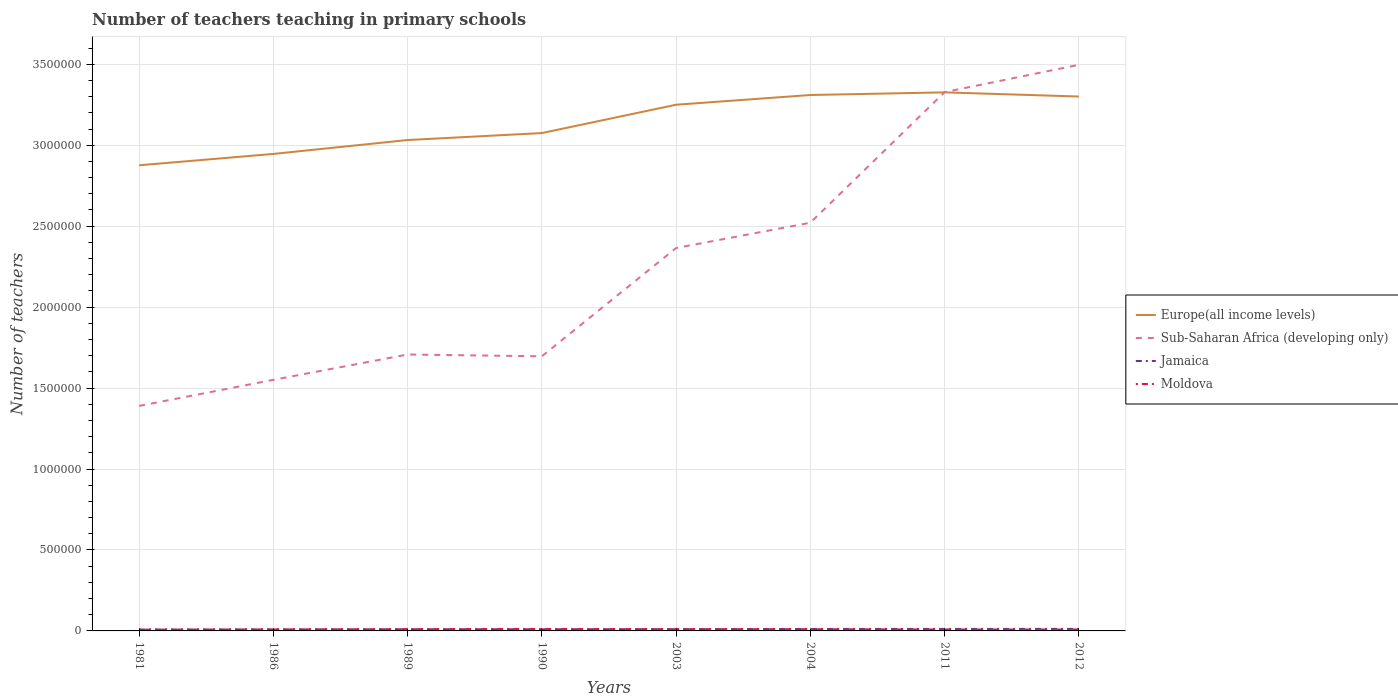How many different coloured lines are there?
Your response must be concise. 4. Does the line corresponding to Jamaica intersect with the line corresponding to Sub-Saharan Africa (developing only)?
Provide a short and direct response. No. Is the number of lines equal to the number of legend labels?
Provide a short and direct response. Yes. Across all years, what is the maximum number of teachers teaching in primary schools in Jamaica?
Provide a succinct answer. 8676. What is the total number of teachers teaching in primary schools in Moldova in the graph?
Offer a terse response. -4067. What is the difference between the highest and the second highest number of teachers teaching in primary schools in Moldova?
Provide a short and direct response. 4067. Is the number of teachers teaching in primary schools in Europe(all income levels) strictly greater than the number of teachers teaching in primary schools in Jamaica over the years?
Your response must be concise. No. How many years are there in the graph?
Make the answer very short. 8. Does the graph contain any zero values?
Your answer should be compact. No. Does the graph contain grids?
Keep it short and to the point. Yes. How many legend labels are there?
Your answer should be compact. 4. How are the legend labels stacked?
Your response must be concise. Vertical. What is the title of the graph?
Your answer should be very brief. Number of teachers teaching in primary schools. Does "Congo (Democratic)" appear as one of the legend labels in the graph?
Provide a short and direct response. No. What is the label or title of the X-axis?
Your response must be concise. Years. What is the label or title of the Y-axis?
Offer a very short reply. Number of teachers. What is the Number of teachers of Europe(all income levels) in 1981?
Keep it short and to the point. 2.88e+06. What is the Number of teachers of Sub-Saharan Africa (developing only) in 1981?
Your answer should be very brief. 1.39e+06. What is the Number of teachers of Jamaica in 1981?
Keep it short and to the point. 8676. What is the Number of teachers of Moldova in 1981?
Make the answer very short. 8003. What is the Number of teachers of Europe(all income levels) in 1986?
Your answer should be compact. 2.95e+06. What is the Number of teachers of Sub-Saharan Africa (developing only) in 1986?
Offer a very short reply. 1.55e+06. What is the Number of teachers in Jamaica in 1986?
Provide a succinct answer. 9648. What is the Number of teachers in Moldova in 1986?
Ensure brevity in your answer.  9500. What is the Number of teachers of Europe(all income levels) in 1989?
Provide a short and direct response. 3.03e+06. What is the Number of teachers in Sub-Saharan Africa (developing only) in 1989?
Give a very brief answer. 1.71e+06. What is the Number of teachers in Jamaica in 1989?
Provide a succinct answer. 1.03e+04. What is the Number of teachers of Moldova in 1989?
Your response must be concise. 1.11e+04. What is the Number of teachers in Europe(all income levels) in 1990?
Your response must be concise. 3.07e+06. What is the Number of teachers in Sub-Saharan Africa (developing only) in 1990?
Give a very brief answer. 1.70e+06. What is the Number of teachers in Jamaica in 1990?
Provide a succinct answer. 1.01e+04. What is the Number of teachers of Moldova in 1990?
Make the answer very short. 1.21e+04. What is the Number of teachers of Europe(all income levels) in 2003?
Your answer should be compact. 3.25e+06. What is the Number of teachers in Sub-Saharan Africa (developing only) in 2003?
Offer a terse response. 2.37e+06. What is the Number of teachers in Jamaica in 2003?
Offer a terse response. 1.10e+04. What is the Number of teachers in Moldova in 2003?
Keep it short and to the point. 1.11e+04. What is the Number of teachers in Europe(all income levels) in 2004?
Offer a very short reply. 3.31e+06. What is the Number of teachers in Sub-Saharan Africa (developing only) in 2004?
Your response must be concise. 2.52e+06. What is the Number of teachers of Jamaica in 2004?
Ensure brevity in your answer.  1.20e+04. What is the Number of teachers in Moldova in 2004?
Provide a succinct answer. 1.05e+04. What is the Number of teachers of Europe(all income levels) in 2011?
Provide a short and direct response. 3.33e+06. What is the Number of teachers in Sub-Saharan Africa (developing only) in 2011?
Offer a very short reply. 3.33e+06. What is the Number of teachers in Jamaica in 2011?
Your answer should be very brief. 1.24e+04. What is the Number of teachers of Moldova in 2011?
Ensure brevity in your answer.  9037. What is the Number of teachers of Europe(all income levels) in 2012?
Offer a very short reply. 3.30e+06. What is the Number of teachers in Sub-Saharan Africa (developing only) in 2012?
Provide a succinct answer. 3.50e+06. What is the Number of teachers of Jamaica in 2012?
Your response must be concise. 1.24e+04. What is the Number of teachers in Moldova in 2012?
Ensure brevity in your answer.  8747. Across all years, what is the maximum Number of teachers of Europe(all income levels)?
Your answer should be very brief. 3.33e+06. Across all years, what is the maximum Number of teachers of Sub-Saharan Africa (developing only)?
Make the answer very short. 3.50e+06. Across all years, what is the maximum Number of teachers of Jamaica?
Keep it short and to the point. 1.24e+04. Across all years, what is the maximum Number of teachers of Moldova?
Keep it short and to the point. 1.21e+04. Across all years, what is the minimum Number of teachers of Europe(all income levels)?
Keep it short and to the point. 2.88e+06. Across all years, what is the minimum Number of teachers in Sub-Saharan Africa (developing only)?
Offer a very short reply. 1.39e+06. Across all years, what is the minimum Number of teachers of Jamaica?
Your response must be concise. 8676. Across all years, what is the minimum Number of teachers in Moldova?
Offer a terse response. 8003. What is the total Number of teachers in Europe(all income levels) in the graph?
Give a very brief answer. 2.51e+07. What is the total Number of teachers of Sub-Saharan Africa (developing only) in the graph?
Your response must be concise. 1.81e+07. What is the total Number of teachers of Jamaica in the graph?
Keep it short and to the point. 8.64e+04. What is the total Number of teachers in Moldova in the graph?
Your answer should be compact. 8.00e+04. What is the difference between the Number of teachers of Europe(all income levels) in 1981 and that in 1986?
Provide a succinct answer. -7.02e+04. What is the difference between the Number of teachers in Sub-Saharan Africa (developing only) in 1981 and that in 1986?
Your answer should be very brief. -1.61e+05. What is the difference between the Number of teachers of Jamaica in 1981 and that in 1986?
Make the answer very short. -972. What is the difference between the Number of teachers of Moldova in 1981 and that in 1986?
Make the answer very short. -1497. What is the difference between the Number of teachers in Europe(all income levels) in 1981 and that in 1989?
Offer a very short reply. -1.56e+05. What is the difference between the Number of teachers of Sub-Saharan Africa (developing only) in 1981 and that in 1989?
Offer a terse response. -3.18e+05. What is the difference between the Number of teachers of Jamaica in 1981 and that in 1989?
Your answer should be compact. -1575. What is the difference between the Number of teachers in Moldova in 1981 and that in 1989?
Your response must be concise. -3102. What is the difference between the Number of teachers of Europe(all income levels) in 1981 and that in 1990?
Your answer should be compact. -1.99e+05. What is the difference between the Number of teachers in Sub-Saharan Africa (developing only) in 1981 and that in 1990?
Ensure brevity in your answer.  -3.07e+05. What is the difference between the Number of teachers of Jamaica in 1981 and that in 1990?
Ensure brevity in your answer.  -1400. What is the difference between the Number of teachers of Moldova in 1981 and that in 1990?
Your response must be concise. -4067. What is the difference between the Number of teachers in Europe(all income levels) in 1981 and that in 2003?
Your answer should be compact. -3.74e+05. What is the difference between the Number of teachers of Sub-Saharan Africa (developing only) in 1981 and that in 2003?
Your response must be concise. -9.75e+05. What is the difference between the Number of teachers in Jamaica in 1981 and that in 2003?
Provide a short and direct response. -2292. What is the difference between the Number of teachers of Moldova in 1981 and that in 2003?
Provide a succinct answer. -3084. What is the difference between the Number of teachers in Europe(all income levels) in 1981 and that in 2004?
Make the answer very short. -4.34e+05. What is the difference between the Number of teachers in Sub-Saharan Africa (developing only) in 1981 and that in 2004?
Offer a very short reply. -1.13e+06. What is the difference between the Number of teachers of Jamaica in 1981 and that in 2004?
Provide a succinct answer. -3356. What is the difference between the Number of teachers of Moldova in 1981 and that in 2004?
Offer a very short reply. -2490. What is the difference between the Number of teachers of Europe(all income levels) in 1981 and that in 2011?
Keep it short and to the point. -4.50e+05. What is the difference between the Number of teachers in Sub-Saharan Africa (developing only) in 1981 and that in 2011?
Offer a very short reply. -1.94e+06. What is the difference between the Number of teachers of Jamaica in 1981 and that in 2011?
Keep it short and to the point. -3704. What is the difference between the Number of teachers in Moldova in 1981 and that in 2011?
Your answer should be very brief. -1034. What is the difference between the Number of teachers of Europe(all income levels) in 1981 and that in 2012?
Your response must be concise. -4.25e+05. What is the difference between the Number of teachers of Sub-Saharan Africa (developing only) in 1981 and that in 2012?
Give a very brief answer. -2.11e+06. What is the difference between the Number of teachers in Jamaica in 1981 and that in 2012?
Your response must be concise. -3733. What is the difference between the Number of teachers of Moldova in 1981 and that in 2012?
Provide a short and direct response. -744. What is the difference between the Number of teachers in Europe(all income levels) in 1986 and that in 1989?
Your response must be concise. -8.58e+04. What is the difference between the Number of teachers in Sub-Saharan Africa (developing only) in 1986 and that in 1989?
Your response must be concise. -1.56e+05. What is the difference between the Number of teachers of Jamaica in 1986 and that in 1989?
Your response must be concise. -603. What is the difference between the Number of teachers of Moldova in 1986 and that in 1989?
Your response must be concise. -1605. What is the difference between the Number of teachers of Europe(all income levels) in 1986 and that in 1990?
Make the answer very short. -1.29e+05. What is the difference between the Number of teachers of Sub-Saharan Africa (developing only) in 1986 and that in 1990?
Give a very brief answer. -1.45e+05. What is the difference between the Number of teachers in Jamaica in 1986 and that in 1990?
Your response must be concise. -428. What is the difference between the Number of teachers of Moldova in 1986 and that in 1990?
Your answer should be very brief. -2570. What is the difference between the Number of teachers in Europe(all income levels) in 1986 and that in 2003?
Make the answer very short. -3.04e+05. What is the difference between the Number of teachers in Sub-Saharan Africa (developing only) in 1986 and that in 2003?
Ensure brevity in your answer.  -8.14e+05. What is the difference between the Number of teachers in Jamaica in 1986 and that in 2003?
Provide a succinct answer. -1320. What is the difference between the Number of teachers in Moldova in 1986 and that in 2003?
Give a very brief answer. -1587. What is the difference between the Number of teachers in Europe(all income levels) in 1986 and that in 2004?
Your answer should be very brief. -3.64e+05. What is the difference between the Number of teachers in Sub-Saharan Africa (developing only) in 1986 and that in 2004?
Keep it short and to the point. -9.70e+05. What is the difference between the Number of teachers of Jamaica in 1986 and that in 2004?
Your response must be concise. -2384. What is the difference between the Number of teachers in Moldova in 1986 and that in 2004?
Keep it short and to the point. -993. What is the difference between the Number of teachers of Europe(all income levels) in 1986 and that in 2011?
Your answer should be very brief. -3.80e+05. What is the difference between the Number of teachers of Sub-Saharan Africa (developing only) in 1986 and that in 2011?
Offer a very short reply. -1.78e+06. What is the difference between the Number of teachers in Jamaica in 1986 and that in 2011?
Keep it short and to the point. -2732. What is the difference between the Number of teachers in Moldova in 1986 and that in 2011?
Give a very brief answer. 463. What is the difference between the Number of teachers in Europe(all income levels) in 1986 and that in 2012?
Keep it short and to the point. -3.54e+05. What is the difference between the Number of teachers of Sub-Saharan Africa (developing only) in 1986 and that in 2012?
Offer a terse response. -1.95e+06. What is the difference between the Number of teachers of Jamaica in 1986 and that in 2012?
Provide a short and direct response. -2761. What is the difference between the Number of teachers of Moldova in 1986 and that in 2012?
Offer a terse response. 753. What is the difference between the Number of teachers of Europe(all income levels) in 1989 and that in 1990?
Make the answer very short. -4.30e+04. What is the difference between the Number of teachers of Sub-Saharan Africa (developing only) in 1989 and that in 1990?
Provide a short and direct response. 1.11e+04. What is the difference between the Number of teachers of Jamaica in 1989 and that in 1990?
Give a very brief answer. 175. What is the difference between the Number of teachers in Moldova in 1989 and that in 1990?
Offer a very short reply. -965. What is the difference between the Number of teachers of Europe(all income levels) in 1989 and that in 2003?
Provide a succinct answer. -2.18e+05. What is the difference between the Number of teachers in Sub-Saharan Africa (developing only) in 1989 and that in 2003?
Provide a short and direct response. -6.58e+05. What is the difference between the Number of teachers in Jamaica in 1989 and that in 2003?
Keep it short and to the point. -717. What is the difference between the Number of teachers of Europe(all income levels) in 1989 and that in 2004?
Your answer should be compact. -2.78e+05. What is the difference between the Number of teachers of Sub-Saharan Africa (developing only) in 1989 and that in 2004?
Provide a succinct answer. -8.14e+05. What is the difference between the Number of teachers in Jamaica in 1989 and that in 2004?
Make the answer very short. -1781. What is the difference between the Number of teachers of Moldova in 1989 and that in 2004?
Your response must be concise. 612. What is the difference between the Number of teachers in Europe(all income levels) in 1989 and that in 2011?
Provide a short and direct response. -2.94e+05. What is the difference between the Number of teachers in Sub-Saharan Africa (developing only) in 1989 and that in 2011?
Make the answer very short. -1.62e+06. What is the difference between the Number of teachers of Jamaica in 1989 and that in 2011?
Offer a terse response. -2129. What is the difference between the Number of teachers of Moldova in 1989 and that in 2011?
Offer a terse response. 2068. What is the difference between the Number of teachers in Europe(all income levels) in 1989 and that in 2012?
Keep it short and to the point. -2.69e+05. What is the difference between the Number of teachers of Sub-Saharan Africa (developing only) in 1989 and that in 2012?
Provide a succinct answer. -1.79e+06. What is the difference between the Number of teachers in Jamaica in 1989 and that in 2012?
Ensure brevity in your answer.  -2158. What is the difference between the Number of teachers of Moldova in 1989 and that in 2012?
Your response must be concise. 2358. What is the difference between the Number of teachers of Europe(all income levels) in 1990 and that in 2003?
Your answer should be very brief. -1.75e+05. What is the difference between the Number of teachers in Sub-Saharan Africa (developing only) in 1990 and that in 2003?
Give a very brief answer. -6.69e+05. What is the difference between the Number of teachers of Jamaica in 1990 and that in 2003?
Provide a short and direct response. -892. What is the difference between the Number of teachers in Moldova in 1990 and that in 2003?
Offer a very short reply. 983. What is the difference between the Number of teachers of Europe(all income levels) in 1990 and that in 2004?
Your answer should be very brief. -2.35e+05. What is the difference between the Number of teachers of Sub-Saharan Africa (developing only) in 1990 and that in 2004?
Give a very brief answer. -8.25e+05. What is the difference between the Number of teachers of Jamaica in 1990 and that in 2004?
Your response must be concise. -1956. What is the difference between the Number of teachers of Moldova in 1990 and that in 2004?
Offer a very short reply. 1577. What is the difference between the Number of teachers of Europe(all income levels) in 1990 and that in 2011?
Your answer should be very brief. -2.51e+05. What is the difference between the Number of teachers of Sub-Saharan Africa (developing only) in 1990 and that in 2011?
Give a very brief answer. -1.63e+06. What is the difference between the Number of teachers of Jamaica in 1990 and that in 2011?
Ensure brevity in your answer.  -2304. What is the difference between the Number of teachers in Moldova in 1990 and that in 2011?
Give a very brief answer. 3033. What is the difference between the Number of teachers of Europe(all income levels) in 1990 and that in 2012?
Ensure brevity in your answer.  -2.26e+05. What is the difference between the Number of teachers of Sub-Saharan Africa (developing only) in 1990 and that in 2012?
Provide a short and direct response. -1.80e+06. What is the difference between the Number of teachers of Jamaica in 1990 and that in 2012?
Offer a very short reply. -2333. What is the difference between the Number of teachers in Moldova in 1990 and that in 2012?
Make the answer very short. 3323. What is the difference between the Number of teachers in Europe(all income levels) in 2003 and that in 2004?
Provide a short and direct response. -6.00e+04. What is the difference between the Number of teachers in Sub-Saharan Africa (developing only) in 2003 and that in 2004?
Offer a very short reply. -1.56e+05. What is the difference between the Number of teachers of Jamaica in 2003 and that in 2004?
Provide a succinct answer. -1064. What is the difference between the Number of teachers in Moldova in 2003 and that in 2004?
Offer a very short reply. 594. What is the difference between the Number of teachers of Europe(all income levels) in 2003 and that in 2011?
Your response must be concise. -7.64e+04. What is the difference between the Number of teachers of Sub-Saharan Africa (developing only) in 2003 and that in 2011?
Your answer should be very brief. -9.63e+05. What is the difference between the Number of teachers in Jamaica in 2003 and that in 2011?
Your answer should be compact. -1412. What is the difference between the Number of teachers of Moldova in 2003 and that in 2011?
Give a very brief answer. 2050. What is the difference between the Number of teachers in Europe(all income levels) in 2003 and that in 2012?
Ensure brevity in your answer.  -5.06e+04. What is the difference between the Number of teachers in Sub-Saharan Africa (developing only) in 2003 and that in 2012?
Give a very brief answer. -1.13e+06. What is the difference between the Number of teachers in Jamaica in 2003 and that in 2012?
Keep it short and to the point. -1441. What is the difference between the Number of teachers of Moldova in 2003 and that in 2012?
Make the answer very short. 2340. What is the difference between the Number of teachers in Europe(all income levels) in 2004 and that in 2011?
Provide a short and direct response. -1.64e+04. What is the difference between the Number of teachers of Sub-Saharan Africa (developing only) in 2004 and that in 2011?
Offer a terse response. -8.07e+05. What is the difference between the Number of teachers of Jamaica in 2004 and that in 2011?
Your response must be concise. -348. What is the difference between the Number of teachers in Moldova in 2004 and that in 2011?
Provide a succinct answer. 1456. What is the difference between the Number of teachers of Europe(all income levels) in 2004 and that in 2012?
Offer a terse response. 9442.75. What is the difference between the Number of teachers in Sub-Saharan Africa (developing only) in 2004 and that in 2012?
Offer a very short reply. -9.75e+05. What is the difference between the Number of teachers of Jamaica in 2004 and that in 2012?
Your response must be concise. -377. What is the difference between the Number of teachers in Moldova in 2004 and that in 2012?
Offer a very short reply. 1746. What is the difference between the Number of teachers in Europe(all income levels) in 2011 and that in 2012?
Provide a succinct answer. 2.58e+04. What is the difference between the Number of teachers in Sub-Saharan Africa (developing only) in 2011 and that in 2012?
Offer a terse response. -1.69e+05. What is the difference between the Number of teachers in Jamaica in 2011 and that in 2012?
Your response must be concise. -29. What is the difference between the Number of teachers in Moldova in 2011 and that in 2012?
Your response must be concise. 290. What is the difference between the Number of teachers of Europe(all income levels) in 1981 and the Number of teachers of Sub-Saharan Africa (developing only) in 1986?
Your answer should be very brief. 1.33e+06. What is the difference between the Number of teachers in Europe(all income levels) in 1981 and the Number of teachers in Jamaica in 1986?
Give a very brief answer. 2.87e+06. What is the difference between the Number of teachers of Europe(all income levels) in 1981 and the Number of teachers of Moldova in 1986?
Your response must be concise. 2.87e+06. What is the difference between the Number of teachers of Sub-Saharan Africa (developing only) in 1981 and the Number of teachers of Jamaica in 1986?
Provide a succinct answer. 1.38e+06. What is the difference between the Number of teachers of Sub-Saharan Africa (developing only) in 1981 and the Number of teachers of Moldova in 1986?
Your answer should be compact. 1.38e+06. What is the difference between the Number of teachers in Jamaica in 1981 and the Number of teachers in Moldova in 1986?
Ensure brevity in your answer.  -824. What is the difference between the Number of teachers of Europe(all income levels) in 1981 and the Number of teachers of Sub-Saharan Africa (developing only) in 1989?
Your answer should be very brief. 1.17e+06. What is the difference between the Number of teachers of Europe(all income levels) in 1981 and the Number of teachers of Jamaica in 1989?
Offer a terse response. 2.87e+06. What is the difference between the Number of teachers in Europe(all income levels) in 1981 and the Number of teachers in Moldova in 1989?
Ensure brevity in your answer.  2.86e+06. What is the difference between the Number of teachers in Sub-Saharan Africa (developing only) in 1981 and the Number of teachers in Jamaica in 1989?
Your answer should be very brief. 1.38e+06. What is the difference between the Number of teachers in Sub-Saharan Africa (developing only) in 1981 and the Number of teachers in Moldova in 1989?
Offer a very short reply. 1.38e+06. What is the difference between the Number of teachers of Jamaica in 1981 and the Number of teachers of Moldova in 1989?
Offer a terse response. -2429. What is the difference between the Number of teachers in Europe(all income levels) in 1981 and the Number of teachers in Sub-Saharan Africa (developing only) in 1990?
Offer a very short reply. 1.18e+06. What is the difference between the Number of teachers of Europe(all income levels) in 1981 and the Number of teachers of Jamaica in 1990?
Provide a short and direct response. 2.87e+06. What is the difference between the Number of teachers in Europe(all income levels) in 1981 and the Number of teachers in Moldova in 1990?
Make the answer very short. 2.86e+06. What is the difference between the Number of teachers of Sub-Saharan Africa (developing only) in 1981 and the Number of teachers of Jamaica in 1990?
Ensure brevity in your answer.  1.38e+06. What is the difference between the Number of teachers of Sub-Saharan Africa (developing only) in 1981 and the Number of teachers of Moldova in 1990?
Offer a very short reply. 1.38e+06. What is the difference between the Number of teachers in Jamaica in 1981 and the Number of teachers in Moldova in 1990?
Give a very brief answer. -3394. What is the difference between the Number of teachers of Europe(all income levels) in 1981 and the Number of teachers of Sub-Saharan Africa (developing only) in 2003?
Your answer should be very brief. 5.11e+05. What is the difference between the Number of teachers of Europe(all income levels) in 1981 and the Number of teachers of Jamaica in 2003?
Ensure brevity in your answer.  2.86e+06. What is the difference between the Number of teachers in Europe(all income levels) in 1981 and the Number of teachers in Moldova in 2003?
Your response must be concise. 2.86e+06. What is the difference between the Number of teachers in Sub-Saharan Africa (developing only) in 1981 and the Number of teachers in Jamaica in 2003?
Provide a succinct answer. 1.38e+06. What is the difference between the Number of teachers of Sub-Saharan Africa (developing only) in 1981 and the Number of teachers of Moldova in 2003?
Make the answer very short. 1.38e+06. What is the difference between the Number of teachers in Jamaica in 1981 and the Number of teachers in Moldova in 2003?
Keep it short and to the point. -2411. What is the difference between the Number of teachers of Europe(all income levels) in 1981 and the Number of teachers of Sub-Saharan Africa (developing only) in 2004?
Your answer should be compact. 3.55e+05. What is the difference between the Number of teachers of Europe(all income levels) in 1981 and the Number of teachers of Jamaica in 2004?
Your answer should be compact. 2.86e+06. What is the difference between the Number of teachers in Europe(all income levels) in 1981 and the Number of teachers in Moldova in 2004?
Provide a succinct answer. 2.87e+06. What is the difference between the Number of teachers of Sub-Saharan Africa (developing only) in 1981 and the Number of teachers of Jamaica in 2004?
Give a very brief answer. 1.38e+06. What is the difference between the Number of teachers in Sub-Saharan Africa (developing only) in 1981 and the Number of teachers in Moldova in 2004?
Your answer should be very brief. 1.38e+06. What is the difference between the Number of teachers of Jamaica in 1981 and the Number of teachers of Moldova in 2004?
Provide a succinct answer. -1817. What is the difference between the Number of teachers of Europe(all income levels) in 1981 and the Number of teachers of Sub-Saharan Africa (developing only) in 2011?
Your answer should be very brief. -4.52e+05. What is the difference between the Number of teachers in Europe(all income levels) in 1981 and the Number of teachers in Jamaica in 2011?
Your answer should be very brief. 2.86e+06. What is the difference between the Number of teachers in Europe(all income levels) in 1981 and the Number of teachers in Moldova in 2011?
Offer a terse response. 2.87e+06. What is the difference between the Number of teachers of Sub-Saharan Africa (developing only) in 1981 and the Number of teachers of Jamaica in 2011?
Offer a very short reply. 1.38e+06. What is the difference between the Number of teachers of Sub-Saharan Africa (developing only) in 1981 and the Number of teachers of Moldova in 2011?
Provide a short and direct response. 1.38e+06. What is the difference between the Number of teachers in Jamaica in 1981 and the Number of teachers in Moldova in 2011?
Offer a very short reply. -361. What is the difference between the Number of teachers of Europe(all income levels) in 1981 and the Number of teachers of Sub-Saharan Africa (developing only) in 2012?
Ensure brevity in your answer.  -6.21e+05. What is the difference between the Number of teachers of Europe(all income levels) in 1981 and the Number of teachers of Jamaica in 2012?
Your answer should be very brief. 2.86e+06. What is the difference between the Number of teachers of Europe(all income levels) in 1981 and the Number of teachers of Moldova in 2012?
Offer a terse response. 2.87e+06. What is the difference between the Number of teachers of Sub-Saharan Africa (developing only) in 1981 and the Number of teachers of Jamaica in 2012?
Give a very brief answer. 1.38e+06. What is the difference between the Number of teachers of Sub-Saharan Africa (developing only) in 1981 and the Number of teachers of Moldova in 2012?
Keep it short and to the point. 1.38e+06. What is the difference between the Number of teachers of Jamaica in 1981 and the Number of teachers of Moldova in 2012?
Offer a terse response. -71. What is the difference between the Number of teachers in Europe(all income levels) in 1986 and the Number of teachers in Sub-Saharan Africa (developing only) in 1989?
Offer a very short reply. 1.24e+06. What is the difference between the Number of teachers in Europe(all income levels) in 1986 and the Number of teachers in Jamaica in 1989?
Give a very brief answer. 2.94e+06. What is the difference between the Number of teachers in Europe(all income levels) in 1986 and the Number of teachers in Moldova in 1989?
Provide a short and direct response. 2.94e+06. What is the difference between the Number of teachers in Sub-Saharan Africa (developing only) in 1986 and the Number of teachers in Jamaica in 1989?
Give a very brief answer. 1.54e+06. What is the difference between the Number of teachers in Sub-Saharan Africa (developing only) in 1986 and the Number of teachers in Moldova in 1989?
Provide a succinct answer. 1.54e+06. What is the difference between the Number of teachers in Jamaica in 1986 and the Number of teachers in Moldova in 1989?
Ensure brevity in your answer.  -1457. What is the difference between the Number of teachers of Europe(all income levels) in 1986 and the Number of teachers of Sub-Saharan Africa (developing only) in 1990?
Your response must be concise. 1.25e+06. What is the difference between the Number of teachers in Europe(all income levels) in 1986 and the Number of teachers in Jamaica in 1990?
Your answer should be very brief. 2.94e+06. What is the difference between the Number of teachers in Europe(all income levels) in 1986 and the Number of teachers in Moldova in 1990?
Ensure brevity in your answer.  2.93e+06. What is the difference between the Number of teachers in Sub-Saharan Africa (developing only) in 1986 and the Number of teachers in Jamaica in 1990?
Your response must be concise. 1.54e+06. What is the difference between the Number of teachers of Sub-Saharan Africa (developing only) in 1986 and the Number of teachers of Moldova in 1990?
Keep it short and to the point. 1.54e+06. What is the difference between the Number of teachers of Jamaica in 1986 and the Number of teachers of Moldova in 1990?
Give a very brief answer. -2422. What is the difference between the Number of teachers in Europe(all income levels) in 1986 and the Number of teachers in Sub-Saharan Africa (developing only) in 2003?
Your response must be concise. 5.81e+05. What is the difference between the Number of teachers in Europe(all income levels) in 1986 and the Number of teachers in Jamaica in 2003?
Your answer should be very brief. 2.94e+06. What is the difference between the Number of teachers in Europe(all income levels) in 1986 and the Number of teachers in Moldova in 2003?
Your answer should be compact. 2.94e+06. What is the difference between the Number of teachers in Sub-Saharan Africa (developing only) in 1986 and the Number of teachers in Jamaica in 2003?
Offer a terse response. 1.54e+06. What is the difference between the Number of teachers of Sub-Saharan Africa (developing only) in 1986 and the Number of teachers of Moldova in 2003?
Keep it short and to the point. 1.54e+06. What is the difference between the Number of teachers in Jamaica in 1986 and the Number of teachers in Moldova in 2003?
Provide a short and direct response. -1439. What is the difference between the Number of teachers of Europe(all income levels) in 1986 and the Number of teachers of Sub-Saharan Africa (developing only) in 2004?
Your response must be concise. 4.25e+05. What is the difference between the Number of teachers in Europe(all income levels) in 1986 and the Number of teachers in Jamaica in 2004?
Provide a short and direct response. 2.93e+06. What is the difference between the Number of teachers in Europe(all income levels) in 1986 and the Number of teachers in Moldova in 2004?
Make the answer very short. 2.94e+06. What is the difference between the Number of teachers of Sub-Saharan Africa (developing only) in 1986 and the Number of teachers of Jamaica in 2004?
Your answer should be very brief. 1.54e+06. What is the difference between the Number of teachers of Sub-Saharan Africa (developing only) in 1986 and the Number of teachers of Moldova in 2004?
Keep it short and to the point. 1.54e+06. What is the difference between the Number of teachers in Jamaica in 1986 and the Number of teachers in Moldova in 2004?
Provide a succinct answer. -845. What is the difference between the Number of teachers of Europe(all income levels) in 1986 and the Number of teachers of Sub-Saharan Africa (developing only) in 2011?
Offer a very short reply. -3.82e+05. What is the difference between the Number of teachers in Europe(all income levels) in 1986 and the Number of teachers in Jamaica in 2011?
Offer a very short reply. 2.93e+06. What is the difference between the Number of teachers of Europe(all income levels) in 1986 and the Number of teachers of Moldova in 2011?
Give a very brief answer. 2.94e+06. What is the difference between the Number of teachers of Sub-Saharan Africa (developing only) in 1986 and the Number of teachers of Jamaica in 2011?
Your response must be concise. 1.54e+06. What is the difference between the Number of teachers in Sub-Saharan Africa (developing only) in 1986 and the Number of teachers in Moldova in 2011?
Your answer should be compact. 1.54e+06. What is the difference between the Number of teachers of Jamaica in 1986 and the Number of teachers of Moldova in 2011?
Your response must be concise. 611. What is the difference between the Number of teachers of Europe(all income levels) in 1986 and the Number of teachers of Sub-Saharan Africa (developing only) in 2012?
Keep it short and to the point. -5.50e+05. What is the difference between the Number of teachers of Europe(all income levels) in 1986 and the Number of teachers of Jamaica in 2012?
Offer a terse response. 2.93e+06. What is the difference between the Number of teachers of Europe(all income levels) in 1986 and the Number of teachers of Moldova in 2012?
Give a very brief answer. 2.94e+06. What is the difference between the Number of teachers in Sub-Saharan Africa (developing only) in 1986 and the Number of teachers in Jamaica in 2012?
Your response must be concise. 1.54e+06. What is the difference between the Number of teachers in Sub-Saharan Africa (developing only) in 1986 and the Number of teachers in Moldova in 2012?
Provide a succinct answer. 1.54e+06. What is the difference between the Number of teachers in Jamaica in 1986 and the Number of teachers in Moldova in 2012?
Offer a very short reply. 901. What is the difference between the Number of teachers in Europe(all income levels) in 1989 and the Number of teachers in Sub-Saharan Africa (developing only) in 1990?
Ensure brevity in your answer.  1.34e+06. What is the difference between the Number of teachers in Europe(all income levels) in 1989 and the Number of teachers in Jamaica in 1990?
Provide a short and direct response. 3.02e+06. What is the difference between the Number of teachers in Europe(all income levels) in 1989 and the Number of teachers in Moldova in 1990?
Provide a succinct answer. 3.02e+06. What is the difference between the Number of teachers in Sub-Saharan Africa (developing only) in 1989 and the Number of teachers in Jamaica in 1990?
Make the answer very short. 1.70e+06. What is the difference between the Number of teachers of Sub-Saharan Africa (developing only) in 1989 and the Number of teachers of Moldova in 1990?
Keep it short and to the point. 1.70e+06. What is the difference between the Number of teachers of Jamaica in 1989 and the Number of teachers of Moldova in 1990?
Keep it short and to the point. -1819. What is the difference between the Number of teachers of Europe(all income levels) in 1989 and the Number of teachers of Sub-Saharan Africa (developing only) in 2003?
Provide a short and direct response. 6.67e+05. What is the difference between the Number of teachers of Europe(all income levels) in 1989 and the Number of teachers of Jamaica in 2003?
Provide a succinct answer. 3.02e+06. What is the difference between the Number of teachers in Europe(all income levels) in 1989 and the Number of teachers in Moldova in 2003?
Keep it short and to the point. 3.02e+06. What is the difference between the Number of teachers in Sub-Saharan Africa (developing only) in 1989 and the Number of teachers in Jamaica in 2003?
Ensure brevity in your answer.  1.70e+06. What is the difference between the Number of teachers of Sub-Saharan Africa (developing only) in 1989 and the Number of teachers of Moldova in 2003?
Provide a succinct answer. 1.70e+06. What is the difference between the Number of teachers of Jamaica in 1989 and the Number of teachers of Moldova in 2003?
Make the answer very short. -836. What is the difference between the Number of teachers of Europe(all income levels) in 1989 and the Number of teachers of Sub-Saharan Africa (developing only) in 2004?
Your answer should be compact. 5.11e+05. What is the difference between the Number of teachers in Europe(all income levels) in 1989 and the Number of teachers in Jamaica in 2004?
Make the answer very short. 3.02e+06. What is the difference between the Number of teachers of Europe(all income levels) in 1989 and the Number of teachers of Moldova in 2004?
Your response must be concise. 3.02e+06. What is the difference between the Number of teachers of Sub-Saharan Africa (developing only) in 1989 and the Number of teachers of Jamaica in 2004?
Offer a terse response. 1.70e+06. What is the difference between the Number of teachers of Sub-Saharan Africa (developing only) in 1989 and the Number of teachers of Moldova in 2004?
Ensure brevity in your answer.  1.70e+06. What is the difference between the Number of teachers in Jamaica in 1989 and the Number of teachers in Moldova in 2004?
Keep it short and to the point. -242. What is the difference between the Number of teachers of Europe(all income levels) in 1989 and the Number of teachers of Sub-Saharan Africa (developing only) in 2011?
Offer a very short reply. -2.96e+05. What is the difference between the Number of teachers of Europe(all income levels) in 1989 and the Number of teachers of Jamaica in 2011?
Give a very brief answer. 3.02e+06. What is the difference between the Number of teachers of Europe(all income levels) in 1989 and the Number of teachers of Moldova in 2011?
Your answer should be compact. 3.02e+06. What is the difference between the Number of teachers in Sub-Saharan Africa (developing only) in 1989 and the Number of teachers in Jamaica in 2011?
Your answer should be very brief. 1.69e+06. What is the difference between the Number of teachers of Sub-Saharan Africa (developing only) in 1989 and the Number of teachers of Moldova in 2011?
Your response must be concise. 1.70e+06. What is the difference between the Number of teachers in Jamaica in 1989 and the Number of teachers in Moldova in 2011?
Provide a succinct answer. 1214. What is the difference between the Number of teachers in Europe(all income levels) in 1989 and the Number of teachers in Sub-Saharan Africa (developing only) in 2012?
Ensure brevity in your answer.  -4.65e+05. What is the difference between the Number of teachers of Europe(all income levels) in 1989 and the Number of teachers of Jamaica in 2012?
Give a very brief answer. 3.02e+06. What is the difference between the Number of teachers in Europe(all income levels) in 1989 and the Number of teachers in Moldova in 2012?
Provide a succinct answer. 3.02e+06. What is the difference between the Number of teachers in Sub-Saharan Africa (developing only) in 1989 and the Number of teachers in Jamaica in 2012?
Ensure brevity in your answer.  1.69e+06. What is the difference between the Number of teachers in Sub-Saharan Africa (developing only) in 1989 and the Number of teachers in Moldova in 2012?
Your answer should be compact. 1.70e+06. What is the difference between the Number of teachers of Jamaica in 1989 and the Number of teachers of Moldova in 2012?
Provide a succinct answer. 1504. What is the difference between the Number of teachers of Europe(all income levels) in 1990 and the Number of teachers of Sub-Saharan Africa (developing only) in 2003?
Offer a terse response. 7.10e+05. What is the difference between the Number of teachers in Europe(all income levels) in 1990 and the Number of teachers in Jamaica in 2003?
Offer a very short reply. 3.06e+06. What is the difference between the Number of teachers of Europe(all income levels) in 1990 and the Number of teachers of Moldova in 2003?
Offer a very short reply. 3.06e+06. What is the difference between the Number of teachers in Sub-Saharan Africa (developing only) in 1990 and the Number of teachers in Jamaica in 2003?
Ensure brevity in your answer.  1.69e+06. What is the difference between the Number of teachers in Sub-Saharan Africa (developing only) in 1990 and the Number of teachers in Moldova in 2003?
Provide a short and direct response. 1.69e+06. What is the difference between the Number of teachers in Jamaica in 1990 and the Number of teachers in Moldova in 2003?
Your answer should be compact. -1011. What is the difference between the Number of teachers of Europe(all income levels) in 1990 and the Number of teachers of Sub-Saharan Africa (developing only) in 2004?
Your answer should be very brief. 5.54e+05. What is the difference between the Number of teachers in Europe(all income levels) in 1990 and the Number of teachers in Jamaica in 2004?
Provide a succinct answer. 3.06e+06. What is the difference between the Number of teachers in Europe(all income levels) in 1990 and the Number of teachers in Moldova in 2004?
Keep it short and to the point. 3.06e+06. What is the difference between the Number of teachers in Sub-Saharan Africa (developing only) in 1990 and the Number of teachers in Jamaica in 2004?
Provide a succinct answer. 1.68e+06. What is the difference between the Number of teachers of Sub-Saharan Africa (developing only) in 1990 and the Number of teachers of Moldova in 2004?
Your answer should be compact. 1.69e+06. What is the difference between the Number of teachers of Jamaica in 1990 and the Number of teachers of Moldova in 2004?
Ensure brevity in your answer.  -417. What is the difference between the Number of teachers of Europe(all income levels) in 1990 and the Number of teachers of Sub-Saharan Africa (developing only) in 2011?
Give a very brief answer. -2.53e+05. What is the difference between the Number of teachers of Europe(all income levels) in 1990 and the Number of teachers of Jamaica in 2011?
Ensure brevity in your answer.  3.06e+06. What is the difference between the Number of teachers of Europe(all income levels) in 1990 and the Number of teachers of Moldova in 2011?
Your answer should be compact. 3.07e+06. What is the difference between the Number of teachers of Sub-Saharan Africa (developing only) in 1990 and the Number of teachers of Jamaica in 2011?
Ensure brevity in your answer.  1.68e+06. What is the difference between the Number of teachers in Sub-Saharan Africa (developing only) in 1990 and the Number of teachers in Moldova in 2011?
Provide a succinct answer. 1.69e+06. What is the difference between the Number of teachers of Jamaica in 1990 and the Number of teachers of Moldova in 2011?
Your answer should be compact. 1039. What is the difference between the Number of teachers of Europe(all income levels) in 1990 and the Number of teachers of Sub-Saharan Africa (developing only) in 2012?
Keep it short and to the point. -4.22e+05. What is the difference between the Number of teachers in Europe(all income levels) in 1990 and the Number of teachers in Jamaica in 2012?
Ensure brevity in your answer.  3.06e+06. What is the difference between the Number of teachers in Europe(all income levels) in 1990 and the Number of teachers in Moldova in 2012?
Keep it short and to the point. 3.07e+06. What is the difference between the Number of teachers in Sub-Saharan Africa (developing only) in 1990 and the Number of teachers in Jamaica in 2012?
Offer a very short reply. 1.68e+06. What is the difference between the Number of teachers of Sub-Saharan Africa (developing only) in 1990 and the Number of teachers of Moldova in 2012?
Provide a short and direct response. 1.69e+06. What is the difference between the Number of teachers in Jamaica in 1990 and the Number of teachers in Moldova in 2012?
Keep it short and to the point. 1329. What is the difference between the Number of teachers of Europe(all income levels) in 2003 and the Number of teachers of Sub-Saharan Africa (developing only) in 2004?
Keep it short and to the point. 7.29e+05. What is the difference between the Number of teachers in Europe(all income levels) in 2003 and the Number of teachers in Jamaica in 2004?
Ensure brevity in your answer.  3.24e+06. What is the difference between the Number of teachers in Europe(all income levels) in 2003 and the Number of teachers in Moldova in 2004?
Keep it short and to the point. 3.24e+06. What is the difference between the Number of teachers in Sub-Saharan Africa (developing only) in 2003 and the Number of teachers in Jamaica in 2004?
Keep it short and to the point. 2.35e+06. What is the difference between the Number of teachers of Sub-Saharan Africa (developing only) in 2003 and the Number of teachers of Moldova in 2004?
Give a very brief answer. 2.35e+06. What is the difference between the Number of teachers of Jamaica in 2003 and the Number of teachers of Moldova in 2004?
Your response must be concise. 475. What is the difference between the Number of teachers in Europe(all income levels) in 2003 and the Number of teachers in Sub-Saharan Africa (developing only) in 2011?
Keep it short and to the point. -7.78e+04. What is the difference between the Number of teachers in Europe(all income levels) in 2003 and the Number of teachers in Jamaica in 2011?
Offer a terse response. 3.24e+06. What is the difference between the Number of teachers of Europe(all income levels) in 2003 and the Number of teachers of Moldova in 2011?
Make the answer very short. 3.24e+06. What is the difference between the Number of teachers of Sub-Saharan Africa (developing only) in 2003 and the Number of teachers of Jamaica in 2011?
Offer a very short reply. 2.35e+06. What is the difference between the Number of teachers in Sub-Saharan Africa (developing only) in 2003 and the Number of teachers in Moldova in 2011?
Offer a very short reply. 2.36e+06. What is the difference between the Number of teachers in Jamaica in 2003 and the Number of teachers in Moldova in 2011?
Your response must be concise. 1931. What is the difference between the Number of teachers in Europe(all income levels) in 2003 and the Number of teachers in Sub-Saharan Africa (developing only) in 2012?
Offer a very short reply. -2.46e+05. What is the difference between the Number of teachers of Europe(all income levels) in 2003 and the Number of teachers of Jamaica in 2012?
Give a very brief answer. 3.24e+06. What is the difference between the Number of teachers in Europe(all income levels) in 2003 and the Number of teachers in Moldova in 2012?
Your answer should be very brief. 3.24e+06. What is the difference between the Number of teachers of Sub-Saharan Africa (developing only) in 2003 and the Number of teachers of Jamaica in 2012?
Keep it short and to the point. 2.35e+06. What is the difference between the Number of teachers in Sub-Saharan Africa (developing only) in 2003 and the Number of teachers in Moldova in 2012?
Give a very brief answer. 2.36e+06. What is the difference between the Number of teachers of Jamaica in 2003 and the Number of teachers of Moldova in 2012?
Keep it short and to the point. 2221. What is the difference between the Number of teachers of Europe(all income levels) in 2004 and the Number of teachers of Sub-Saharan Africa (developing only) in 2011?
Make the answer very short. -1.78e+04. What is the difference between the Number of teachers in Europe(all income levels) in 2004 and the Number of teachers in Jamaica in 2011?
Offer a terse response. 3.30e+06. What is the difference between the Number of teachers of Europe(all income levels) in 2004 and the Number of teachers of Moldova in 2011?
Keep it short and to the point. 3.30e+06. What is the difference between the Number of teachers of Sub-Saharan Africa (developing only) in 2004 and the Number of teachers of Jamaica in 2011?
Keep it short and to the point. 2.51e+06. What is the difference between the Number of teachers of Sub-Saharan Africa (developing only) in 2004 and the Number of teachers of Moldova in 2011?
Keep it short and to the point. 2.51e+06. What is the difference between the Number of teachers in Jamaica in 2004 and the Number of teachers in Moldova in 2011?
Your answer should be very brief. 2995. What is the difference between the Number of teachers of Europe(all income levels) in 2004 and the Number of teachers of Sub-Saharan Africa (developing only) in 2012?
Your response must be concise. -1.86e+05. What is the difference between the Number of teachers of Europe(all income levels) in 2004 and the Number of teachers of Jamaica in 2012?
Offer a very short reply. 3.30e+06. What is the difference between the Number of teachers of Europe(all income levels) in 2004 and the Number of teachers of Moldova in 2012?
Give a very brief answer. 3.30e+06. What is the difference between the Number of teachers in Sub-Saharan Africa (developing only) in 2004 and the Number of teachers in Jamaica in 2012?
Offer a terse response. 2.51e+06. What is the difference between the Number of teachers of Sub-Saharan Africa (developing only) in 2004 and the Number of teachers of Moldova in 2012?
Provide a succinct answer. 2.51e+06. What is the difference between the Number of teachers in Jamaica in 2004 and the Number of teachers in Moldova in 2012?
Your answer should be compact. 3285. What is the difference between the Number of teachers of Europe(all income levels) in 2011 and the Number of teachers of Sub-Saharan Africa (developing only) in 2012?
Your answer should be very brief. -1.70e+05. What is the difference between the Number of teachers in Europe(all income levels) in 2011 and the Number of teachers in Jamaica in 2012?
Ensure brevity in your answer.  3.31e+06. What is the difference between the Number of teachers in Europe(all income levels) in 2011 and the Number of teachers in Moldova in 2012?
Offer a terse response. 3.32e+06. What is the difference between the Number of teachers in Sub-Saharan Africa (developing only) in 2011 and the Number of teachers in Jamaica in 2012?
Your response must be concise. 3.32e+06. What is the difference between the Number of teachers of Sub-Saharan Africa (developing only) in 2011 and the Number of teachers of Moldova in 2012?
Make the answer very short. 3.32e+06. What is the difference between the Number of teachers in Jamaica in 2011 and the Number of teachers in Moldova in 2012?
Keep it short and to the point. 3633. What is the average Number of teachers in Europe(all income levels) per year?
Keep it short and to the point. 3.14e+06. What is the average Number of teachers in Sub-Saharan Africa (developing only) per year?
Keep it short and to the point. 2.26e+06. What is the average Number of teachers in Jamaica per year?
Offer a terse response. 1.08e+04. What is the average Number of teachers of Moldova per year?
Make the answer very short. 1.00e+04. In the year 1981, what is the difference between the Number of teachers of Europe(all income levels) and Number of teachers of Sub-Saharan Africa (developing only)?
Keep it short and to the point. 1.49e+06. In the year 1981, what is the difference between the Number of teachers of Europe(all income levels) and Number of teachers of Jamaica?
Keep it short and to the point. 2.87e+06. In the year 1981, what is the difference between the Number of teachers of Europe(all income levels) and Number of teachers of Moldova?
Your answer should be very brief. 2.87e+06. In the year 1981, what is the difference between the Number of teachers of Sub-Saharan Africa (developing only) and Number of teachers of Jamaica?
Provide a short and direct response. 1.38e+06. In the year 1981, what is the difference between the Number of teachers in Sub-Saharan Africa (developing only) and Number of teachers in Moldova?
Ensure brevity in your answer.  1.38e+06. In the year 1981, what is the difference between the Number of teachers in Jamaica and Number of teachers in Moldova?
Offer a very short reply. 673. In the year 1986, what is the difference between the Number of teachers in Europe(all income levels) and Number of teachers in Sub-Saharan Africa (developing only)?
Your answer should be compact. 1.40e+06. In the year 1986, what is the difference between the Number of teachers of Europe(all income levels) and Number of teachers of Jamaica?
Make the answer very short. 2.94e+06. In the year 1986, what is the difference between the Number of teachers of Europe(all income levels) and Number of teachers of Moldova?
Provide a short and direct response. 2.94e+06. In the year 1986, what is the difference between the Number of teachers in Sub-Saharan Africa (developing only) and Number of teachers in Jamaica?
Ensure brevity in your answer.  1.54e+06. In the year 1986, what is the difference between the Number of teachers in Sub-Saharan Africa (developing only) and Number of teachers in Moldova?
Your answer should be very brief. 1.54e+06. In the year 1986, what is the difference between the Number of teachers of Jamaica and Number of teachers of Moldova?
Make the answer very short. 148. In the year 1989, what is the difference between the Number of teachers in Europe(all income levels) and Number of teachers in Sub-Saharan Africa (developing only)?
Your answer should be compact. 1.32e+06. In the year 1989, what is the difference between the Number of teachers of Europe(all income levels) and Number of teachers of Jamaica?
Offer a terse response. 3.02e+06. In the year 1989, what is the difference between the Number of teachers in Europe(all income levels) and Number of teachers in Moldova?
Give a very brief answer. 3.02e+06. In the year 1989, what is the difference between the Number of teachers in Sub-Saharan Africa (developing only) and Number of teachers in Jamaica?
Keep it short and to the point. 1.70e+06. In the year 1989, what is the difference between the Number of teachers in Sub-Saharan Africa (developing only) and Number of teachers in Moldova?
Make the answer very short. 1.70e+06. In the year 1989, what is the difference between the Number of teachers in Jamaica and Number of teachers in Moldova?
Give a very brief answer. -854. In the year 1990, what is the difference between the Number of teachers in Europe(all income levels) and Number of teachers in Sub-Saharan Africa (developing only)?
Offer a terse response. 1.38e+06. In the year 1990, what is the difference between the Number of teachers of Europe(all income levels) and Number of teachers of Jamaica?
Your answer should be compact. 3.06e+06. In the year 1990, what is the difference between the Number of teachers in Europe(all income levels) and Number of teachers in Moldova?
Offer a terse response. 3.06e+06. In the year 1990, what is the difference between the Number of teachers in Sub-Saharan Africa (developing only) and Number of teachers in Jamaica?
Keep it short and to the point. 1.69e+06. In the year 1990, what is the difference between the Number of teachers in Sub-Saharan Africa (developing only) and Number of teachers in Moldova?
Make the answer very short. 1.68e+06. In the year 1990, what is the difference between the Number of teachers of Jamaica and Number of teachers of Moldova?
Provide a short and direct response. -1994. In the year 2003, what is the difference between the Number of teachers of Europe(all income levels) and Number of teachers of Sub-Saharan Africa (developing only)?
Your answer should be compact. 8.85e+05. In the year 2003, what is the difference between the Number of teachers of Europe(all income levels) and Number of teachers of Jamaica?
Keep it short and to the point. 3.24e+06. In the year 2003, what is the difference between the Number of teachers in Europe(all income levels) and Number of teachers in Moldova?
Ensure brevity in your answer.  3.24e+06. In the year 2003, what is the difference between the Number of teachers of Sub-Saharan Africa (developing only) and Number of teachers of Jamaica?
Provide a short and direct response. 2.35e+06. In the year 2003, what is the difference between the Number of teachers of Sub-Saharan Africa (developing only) and Number of teachers of Moldova?
Ensure brevity in your answer.  2.35e+06. In the year 2003, what is the difference between the Number of teachers in Jamaica and Number of teachers in Moldova?
Give a very brief answer. -119. In the year 2004, what is the difference between the Number of teachers in Europe(all income levels) and Number of teachers in Sub-Saharan Africa (developing only)?
Your response must be concise. 7.89e+05. In the year 2004, what is the difference between the Number of teachers of Europe(all income levels) and Number of teachers of Jamaica?
Offer a terse response. 3.30e+06. In the year 2004, what is the difference between the Number of teachers of Europe(all income levels) and Number of teachers of Moldova?
Your answer should be compact. 3.30e+06. In the year 2004, what is the difference between the Number of teachers in Sub-Saharan Africa (developing only) and Number of teachers in Jamaica?
Your answer should be very brief. 2.51e+06. In the year 2004, what is the difference between the Number of teachers of Sub-Saharan Africa (developing only) and Number of teachers of Moldova?
Your answer should be very brief. 2.51e+06. In the year 2004, what is the difference between the Number of teachers in Jamaica and Number of teachers in Moldova?
Offer a terse response. 1539. In the year 2011, what is the difference between the Number of teachers of Europe(all income levels) and Number of teachers of Sub-Saharan Africa (developing only)?
Your response must be concise. -1405. In the year 2011, what is the difference between the Number of teachers in Europe(all income levels) and Number of teachers in Jamaica?
Offer a terse response. 3.31e+06. In the year 2011, what is the difference between the Number of teachers in Europe(all income levels) and Number of teachers in Moldova?
Your answer should be very brief. 3.32e+06. In the year 2011, what is the difference between the Number of teachers of Sub-Saharan Africa (developing only) and Number of teachers of Jamaica?
Ensure brevity in your answer.  3.32e+06. In the year 2011, what is the difference between the Number of teachers in Sub-Saharan Africa (developing only) and Number of teachers in Moldova?
Your response must be concise. 3.32e+06. In the year 2011, what is the difference between the Number of teachers of Jamaica and Number of teachers of Moldova?
Provide a short and direct response. 3343. In the year 2012, what is the difference between the Number of teachers in Europe(all income levels) and Number of teachers in Sub-Saharan Africa (developing only)?
Keep it short and to the point. -1.96e+05. In the year 2012, what is the difference between the Number of teachers of Europe(all income levels) and Number of teachers of Jamaica?
Ensure brevity in your answer.  3.29e+06. In the year 2012, what is the difference between the Number of teachers of Europe(all income levels) and Number of teachers of Moldova?
Offer a very short reply. 3.29e+06. In the year 2012, what is the difference between the Number of teachers in Sub-Saharan Africa (developing only) and Number of teachers in Jamaica?
Your answer should be very brief. 3.48e+06. In the year 2012, what is the difference between the Number of teachers of Sub-Saharan Africa (developing only) and Number of teachers of Moldova?
Provide a succinct answer. 3.49e+06. In the year 2012, what is the difference between the Number of teachers of Jamaica and Number of teachers of Moldova?
Offer a terse response. 3662. What is the ratio of the Number of teachers in Europe(all income levels) in 1981 to that in 1986?
Your answer should be very brief. 0.98. What is the ratio of the Number of teachers in Sub-Saharan Africa (developing only) in 1981 to that in 1986?
Your answer should be compact. 0.9. What is the ratio of the Number of teachers in Jamaica in 1981 to that in 1986?
Make the answer very short. 0.9. What is the ratio of the Number of teachers of Moldova in 1981 to that in 1986?
Give a very brief answer. 0.84. What is the ratio of the Number of teachers of Europe(all income levels) in 1981 to that in 1989?
Provide a succinct answer. 0.95. What is the ratio of the Number of teachers of Sub-Saharan Africa (developing only) in 1981 to that in 1989?
Provide a succinct answer. 0.81. What is the ratio of the Number of teachers in Jamaica in 1981 to that in 1989?
Your answer should be compact. 0.85. What is the ratio of the Number of teachers of Moldova in 1981 to that in 1989?
Keep it short and to the point. 0.72. What is the ratio of the Number of teachers of Europe(all income levels) in 1981 to that in 1990?
Your answer should be compact. 0.94. What is the ratio of the Number of teachers in Sub-Saharan Africa (developing only) in 1981 to that in 1990?
Your answer should be very brief. 0.82. What is the ratio of the Number of teachers of Jamaica in 1981 to that in 1990?
Your response must be concise. 0.86. What is the ratio of the Number of teachers of Moldova in 1981 to that in 1990?
Offer a very short reply. 0.66. What is the ratio of the Number of teachers in Europe(all income levels) in 1981 to that in 2003?
Offer a terse response. 0.88. What is the ratio of the Number of teachers in Sub-Saharan Africa (developing only) in 1981 to that in 2003?
Give a very brief answer. 0.59. What is the ratio of the Number of teachers in Jamaica in 1981 to that in 2003?
Make the answer very short. 0.79. What is the ratio of the Number of teachers of Moldova in 1981 to that in 2003?
Ensure brevity in your answer.  0.72. What is the ratio of the Number of teachers of Europe(all income levels) in 1981 to that in 2004?
Your answer should be very brief. 0.87. What is the ratio of the Number of teachers of Sub-Saharan Africa (developing only) in 1981 to that in 2004?
Ensure brevity in your answer.  0.55. What is the ratio of the Number of teachers in Jamaica in 1981 to that in 2004?
Provide a succinct answer. 0.72. What is the ratio of the Number of teachers in Moldova in 1981 to that in 2004?
Keep it short and to the point. 0.76. What is the ratio of the Number of teachers in Europe(all income levels) in 1981 to that in 2011?
Provide a short and direct response. 0.86. What is the ratio of the Number of teachers in Sub-Saharan Africa (developing only) in 1981 to that in 2011?
Provide a short and direct response. 0.42. What is the ratio of the Number of teachers in Jamaica in 1981 to that in 2011?
Ensure brevity in your answer.  0.7. What is the ratio of the Number of teachers in Moldova in 1981 to that in 2011?
Offer a very short reply. 0.89. What is the ratio of the Number of teachers in Europe(all income levels) in 1981 to that in 2012?
Ensure brevity in your answer.  0.87. What is the ratio of the Number of teachers of Sub-Saharan Africa (developing only) in 1981 to that in 2012?
Make the answer very short. 0.4. What is the ratio of the Number of teachers of Jamaica in 1981 to that in 2012?
Give a very brief answer. 0.7. What is the ratio of the Number of teachers of Moldova in 1981 to that in 2012?
Provide a short and direct response. 0.91. What is the ratio of the Number of teachers of Europe(all income levels) in 1986 to that in 1989?
Provide a succinct answer. 0.97. What is the ratio of the Number of teachers in Sub-Saharan Africa (developing only) in 1986 to that in 1989?
Your answer should be compact. 0.91. What is the ratio of the Number of teachers of Jamaica in 1986 to that in 1989?
Offer a terse response. 0.94. What is the ratio of the Number of teachers of Moldova in 1986 to that in 1989?
Keep it short and to the point. 0.86. What is the ratio of the Number of teachers of Europe(all income levels) in 1986 to that in 1990?
Your response must be concise. 0.96. What is the ratio of the Number of teachers in Sub-Saharan Africa (developing only) in 1986 to that in 1990?
Make the answer very short. 0.91. What is the ratio of the Number of teachers of Jamaica in 1986 to that in 1990?
Provide a succinct answer. 0.96. What is the ratio of the Number of teachers in Moldova in 1986 to that in 1990?
Your response must be concise. 0.79. What is the ratio of the Number of teachers in Europe(all income levels) in 1986 to that in 2003?
Your answer should be very brief. 0.91. What is the ratio of the Number of teachers in Sub-Saharan Africa (developing only) in 1986 to that in 2003?
Offer a terse response. 0.66. What is the ratio of the Number of teachers in Jamaica in 1986 to that in 2003?
Your answer should be very brief. 0.88. What is the ratio of the Number of teachers in Moldova in 1986 to that in 2003?
Keep it short and to the point. 0.86. What is the ratio of the Number of teachers of Europe(all income levels) in 1986 to that in 2004?
Offer a very short reply. 0.89. What is the ratio of the Number of teachers of Sub-Saharan Africa (developing only) in 1986 to that in 2004?
Offer a terse response. 0.62. What is the ratio of the Number of teachers in Jamaica in 1986 to that in 2004?
Offer a very short reply. 0.8. What is the ratio of the Number of teachers in Moldova in 1986 to that in 2004?
Ensure brevity in your answer.  0.91. What is the ratio of the Number of teachers in Europe(all income levels) in 1986 to that in 2011?
Ensure brevity in your answer.  0.89. What is the ratio of the Number of teachers of Sub-Saharan Africa (developing only) in 1986 to that in 2011?
Make the answer very short. 0.47. What is the ratio of the Number of teachers of Jamaica in 1986 to that in 2011?
Offer a terse response. 0.78. What is the ratio of the Number of teachers of Moldova in 1986 to that in 2011?
Your answer should be very brief. 1.05. What is the ratio of the Number of teachers in Europe(all income levels) in 1986 to that in 2012?
Your response must be concise. 0.89. What is the ratio of the Number of teachers in Sub-Saharan Africa (developing only) in 1986 to that in 2012?
Your answer should be compact. 0.44. What is the ratio of the Number of teachers of Jamaica in 1986 to that in 2012?
Give a very brief answer. 0.78. What is the ratio of the Number of teachers of Moldova in 1986 to that in 2012?
Provide a short and direct response. 1.09. What is the ratio of the Number of teachers in Sub-Saharan Africa (developing only) in 1989 to that in 1990?
Provide a short and direct response. 1.01. What is the ratio of the Number of teachers in Jamaica in 1989 to that in 1990?
Ensure brevity in your answer.  1.02. What is the ratio of the Number of teachers in Moldova in 1989 to that in 1990?
Offer a very short reply. 0.92. What is the ratio of the Number of teachers of Europe(all income levels) in 1989 to that in 2003?
Offer a very short reply. 0.93. What is the ratio of the Number of teachers of Sub-Saharan Africa (developing only) in 1989 to that in 2003?
Your answer should be compact. 0.72. What is the ratio of the Number of teachers in Jamaica in 1989 to that in 2003?
Your response must be concise. 0.93. What is the ratio of the Number of teachers of Moldova in 1989 to that in 2003?
Ensure brevity in your answer.  1. What is the ratio of the Number of teachers in Europe(all income levels) in 1989 to that in 2004?
Offer a very short reply. 0.92. What is the ratio of the Number of teachers in Sub-Saharan Africa (developing only) in 1989 to that in 2004?
Make the answer very short. 0.68. What is the ratio of the Number of teachers of Jamaica in 1989 to that in 2004?
Offer a terse response. 0.85. What is the ratio of the Number of teachers of Moldova in 1989 to that in 2004?
Your answer should be compact. 1.06. What is the ratio of the Number of teachers of Europe(all income levels) in 1989 to that in 2011?
Provide a succinct answer. 0.91. What is the ratio of the Number of teachers in Sub-Saharan Africa (developing only) in 1989 to that in 2011?
Offer a very short reply. 0.51. What is the ratio of the Number of teachers of Jamaica in 1989 to that in 2011?
Keep it short and to the point. 0.83. What is the ratio of the Number of teachers in Moldova in 1989 to that in 2011?
Offer a terse response. 1.23. What is the ratio of the Number of teachers in Europe(all income levels) in 1989 to that in 2012?
Your response must be concise. 0.92. What is the ratio of the Number of teachers in Sub-Saharan Africa (developing only) in 1989 to that in 2012?
Your answer should be very brief. 0.49. What is the ratio of the Number of teachers of Jamaica in 1989 to that in 2012?
Make the answer very short. 0.83. What is the ratio of the Number of teachers in Moldova in 1989 to that in 2012?
Make the answer very short. 1.27. What is the ratio of the Number of teachers of Europe(all income levels) in 1990 to that in 2003?
Offer a terse response. 0.95. What is the ratio of the Number of teachers in Sub-Saharan Africa (developing only) in 1990 to that in 2003?
Provide a short and direct response. 0.72. What is the ratio of the Number of teachers of Jamaica in 1990 to that in 2003?
Offer a very short reply. 0.92. What is the ratio of the Number of teachers of Moldova in 1990 to that in 2003?
Give a very brief answer. 1.09. What is the ratio of the Number of teachers in Europe(all income levels) in 1990 to that in 2004?
Your response must be concise. 0.93. What is the ratio of the Number of teachers of Sub-Saharan Africa (developing only) in 1990 to that in 2004?
Give a very brief answer. 0.67. What is the ratio of the Number of teachers in Jamaica in 1990 to that in 2004?
Ensure brevity in your answer.  0.84. What is the ratio of the Number of teachers in Moldova in 1990 to that in 2004?
Ensure brevity in your answer.  1.15. What is the ratio of the Number of teachers in Europe(all income levels) in 1990 to that in 2011?
Make the answer very short. 0.92. What is the ratio of the Number of teachers of Sub-Saharan Africa (developing only) in 1990 to that in 2011?
Your response must be concise. 0.51. What is the ratio of the Number of teachers in Jamaica in 1990 to that in 2011?
Keep it short and to the point. 0.81. What is the ratio of the Number of teachers of Moldova in 1990 to that in 2011?
Keep it short and to the point. 1.34. What is the ratio of the Number of teachers of Europe(all income levels) in 1990 to that in 2012?
Offer a very short reply. 0.93. What is the ratio of the Number of teachers in Sub-Saharan Africa (developing only) in 1990 to that in 2012?
Make the answer very short. 0.49. What is the ratio of the Number of teachers of Jamaica in 1990 to that in 2012?
Provide a succinct answer. 0.81. What is the ratio of the Number of teachers in Moldova in 1990 to that in 2012?
Offer a terse response. 1.38. What is the ratio of the Number of teachers of Europe(all income levels) in 2003 to that in 2004?
Keep it short and to the point. 0.98. What is the ratio of the Number of teachers of Sub-Saharan Africa (developing only) in 2003 to that in 2004?
Give a very brief answer. 0.94. What is the ratio of the Number of teachers of Jamaica in 2003 to that in 2004?
Provide a short and direct response. 0.91. What is the ratio of the Number of teachers in Moldova in 2003 to that in 2004?
Give a very brief answer. 1.06. What is the ratio of the Number of teachers of Sub-Saharan Africa (developing only) in 2003 to that in 2011?
Your answer should be very brief. 0.71. What is the ratio of the Number of teachers in Jamaica in 2003 to that in 2011?
Make the answer very short. 0.89. What is the ratio of the Number of teachers of Moldova in 2003 to that in 2011?
Offer a very short reply. 1.23. What is the ratio of the Number of teachers of Europe(all income levels) in 2003 to that in 2012?
Make the answer very short. 0.98. What is the ratio of the Number of teachers of Sub-Saharan Africa (developing only) in 2003 to that in 2012?
Your answer should be very brief. 0.68. What is the ratio of the Number of teachers of Jamaica in 2003 to that in 2012?
Offer a terse response. 0.88. What is the ratio of the Number of teachers of Moldova in 2003 to that in 2012?
Ensure brevity in your answer.  1.27. What is the ratio of the Number of teachers in Sub-Saharan Africa (developing only) in 2004 to that in 2011?
Keep it short and to the point. 0.76. What is the ratio of the Number of teachers of Jamaica in 2004 to that in 2011?
Your answer should be very brief. 0.97. What is the ratio of the Number of teachers of Moldova in 2004 to that in 2011?
Provide a short and direct response. 1.16. What is the ratio of the Number of teachers in Europe(all income levels) in 2004 to that in 2012?
Provide a succinct answer. 1. What is the ratio of the Number of teachers of Sub-Saharan Africa (developing only) in 2004 to that in 2012?
Provide a succinct answer. 0.72. What is the ratio of the Number of teachers of Jamaica in 2004 to that in 2012?
Offer a very short reply. 0.97. What is the ratio of the Number of teachers of Moldova in 2004 to that in 2012?
Ensure brevity in your answer.  1.2. What is the ratio of the Number of teachers in Europe(all income levels) in 2011 to that in 2012?
Offer a terse response. 1.01. What is the ratio of the Number of teachers of Sub-Saharan Africa (developing only) in 2011 to that in 2012?
Give a very brief answer. 0.95. What is the ratio of the Number of teachers in Moldova in 2011 to that in 2012?
Offer a terse response. 1.03. What is the difference between the highest and the second highest Number of teachers of Europe(all income levels)?
Keep it short and to the point. 1.64e+04. What is the difference between the highest and the second highest Number of teachers in Sub-Saharan Africa (developing only)?
Keep it short and to the point. 1.69e+05. What is the difference between the highest and the second highest Number of teachers of Moldova?
Make the answer very short. 965. What is the difference between the highest and the lowest Number of teachers in Europe(all income levels)?
Provide a succinct answer. 4.50e+05. What is the difference between the highest and the lowest Number of teachers in Sub-Saharan Africa (developing only)?
Offer a terse response. 2.11e+06. What is the difference between the highest and the lowest Number of teachers of Jamaica?
Offer a terse response. 3733. What is the difference between the highest and the lowest Number of teachers of Moldova?
Ensure brevity in your answer.  4067. 